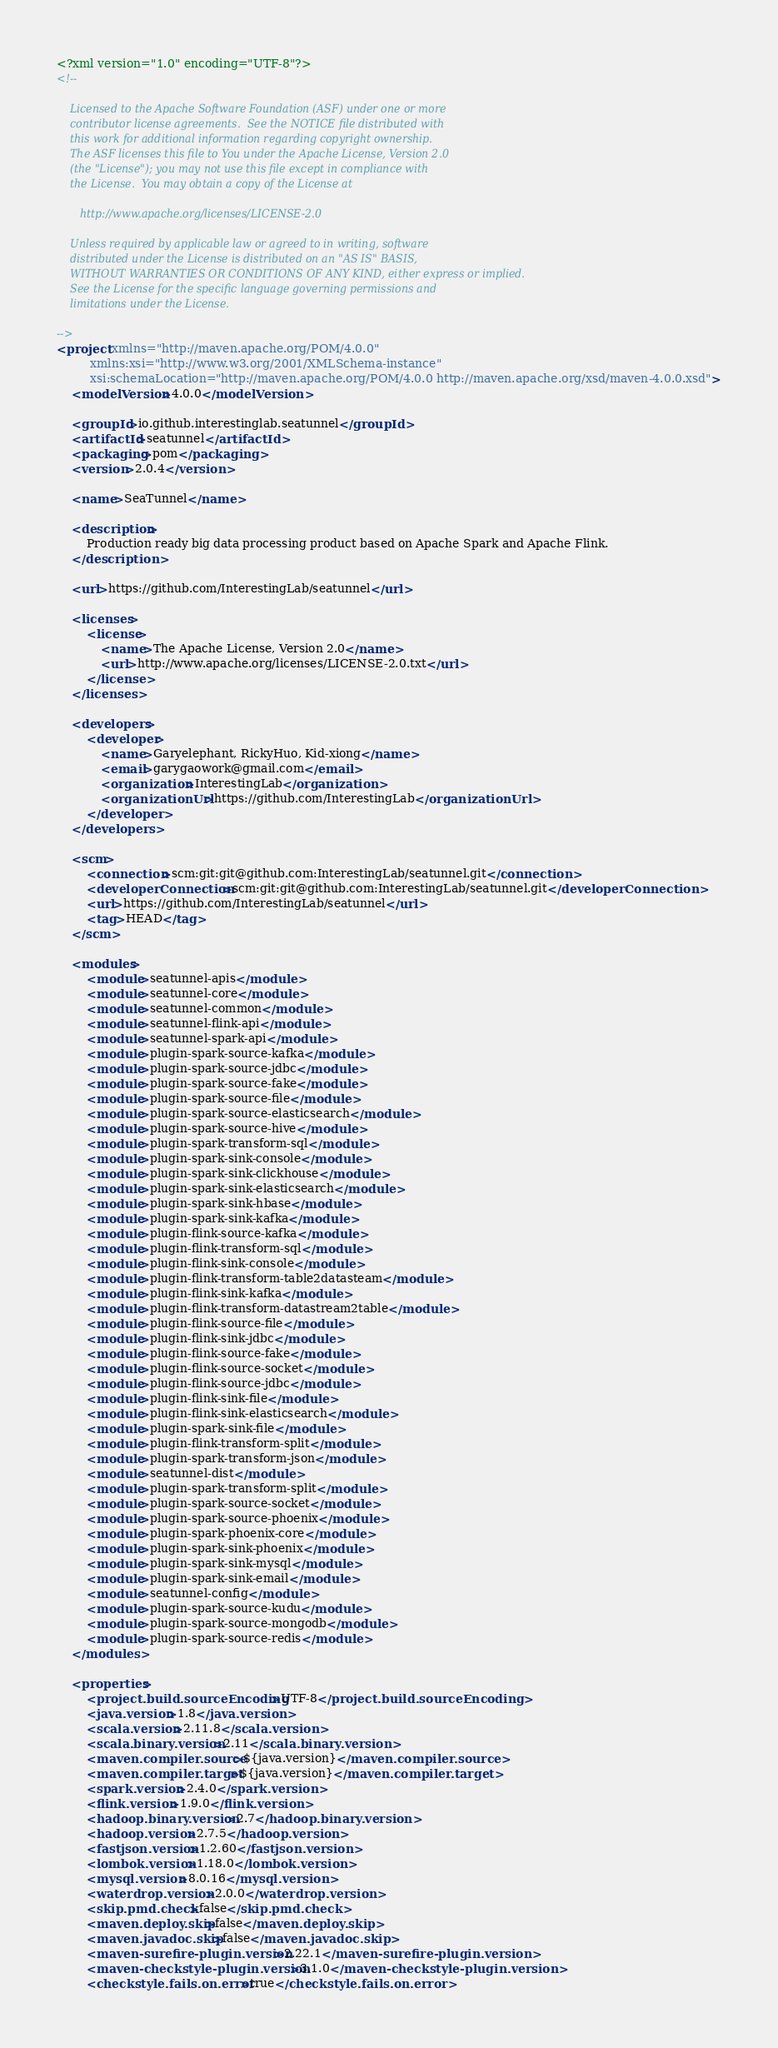<code> <loc_0><loc_0><loc_500><loc_500><_XML_><?xml version="1.0" encoding="UTF-8"?>
<!--

    Licensed to the Apache Software Foundation (ASF) under one or more
    contributor license agreements.  See the NOTICE file distributed with
    this work for additional information regarding copyright ownership.
    The ASF licenses this file to You under the Apache License, Version 2.0
    (the "License"); you may not use this file except in compliance with
    the License.  You may obtain a copy of the License at

       http://www.apache.org/licenses/LICENSE-2.0

    Unless required by applicable law or agreed to in writing, software
    distributed under the License is distributed on an "AS IS" BASIS,
    WITHOUT WARRANTIES OR CONDITIONS OF ANY KIND, either express or implied.
    See the License for the specific language governing permissions and
    limitations under the License.

-->
<project xmlns="http://maven.apache.org/POM/4.0.0"
         xmlns:xsi="http://www.w3.org/2001/XMLSchema-instance"
         xsi:schemaLocation="http://maven.apache.org/POM/4.0.0 http://maven.apache.org/xsd/maven-4.0.0.xsd">
    <modelVersion>4.0.0</modelVersion>

    <groupId>io.github.interestinglab.seatunnel</groupId>
    <artifactId>seatunnel</artifactId>
    <packaging>pom</packaging>
    <version>2.0.4</version>

    <name>SeaTunnel</name>

    <description>
        Production ready big data processing product based on Apache Spark and Apache Flink.
    </description>

    <url>https://github.com/InterestingLab/seatunnel</url>

    <licenses>
        <license>
            <name>The Apache License, Version 2.0</name>
            <url>http://www.apache.org/licenses/LICENSE-2.0.txt</url>
        </license>
    </licenses>

    <developers>
        <developer>
            <name>Garyelephant, RickyHuo, Kid-xiong</name>
            <email>garygaowork@gmail.com</email>
            <organization>InterestingLab</organization>
            <organizationUrl>https://github.com/InterestingLab</organizationUrl>
        </developer>
    </developers>

    <scm>
        <connection>scm:git:git@github.com:InterestingLab/seatunnel.git</connection>
        <developerConnection>scm:git:git@github.com:InterestingLab/seatunnel.git</developerConnection>
        <url>https://github.com/InterestingLab/seatunnel</url>
        <tag>HEAD</tag>
    </scm>

    <modules>
        <module>seatunnel-apis</module>
        <module>seatunnel-core</module>
        <module>seatunnel-common</module>
        <module>seatunnel-flink-api</module>
        <module>seatunnel-spark-api</module>
        <module>plugin-spark-source-kafka</module>
        <module>plugin-spark-source-jdbc</module>
        <module>plugin-spark-source-fake</module>
        <module>plugin-spark-source-file</module>
        <module>plugin-spark-source-elasticsearch</module>
        <module>plugin-spark-source-hive</module>
        <module>plugin-spark-transform-sql</module>
        <module>plugin-spark-sink-console</module>
        <module>plugin-spark-sink-clickhouse</module>
        <module>plugin-spark-sink-elasticsearch</module>
        <module>plugin-spark-sink-hbase</module>
        <module>plugin-spark-sink-kafka</module>
        <module>plugin-flink-source-kafka</module>
        <module>plugin-flink-transform-sql</module>
        <module>plugin-flink-sink-console</module>
        <module>plugin-flink-transform-table2datasteam</module>
        <module>plugin-flink-sink-kafka</module>
        <module>plugin-flink-transform-datastream2table</module>
        <module>plugin-flink-source-file</module>
        <module>plugin-flink-sink-jdbc</module>
        <module>plugin-flink-source-fake</module>
        <module>plugin-flink-source-socket</module>
        <module>plugin-flink-source-jdbc</module>
        <module>plugin-flink-sink-file</module>
        <module>plugin-flink-sink-elasticsearch</module>
        <module>plugin-spark-sink-file</module>
        <module>plugin-flink-transform-split</module>
        <module>plugin-spark-transform-json</module>
        <module>seatunnel-dist</module>
        <module>plugin-spark-transform-split</module>
        <module>plugin-spark-source-socket</module>
        <module>plugin-spark-source-phoenix</module>
        <module>plugin-spark-phoenix-core</module>
        <module>plugin-spark-sink-phoenix</module>
        <module>plugin-spark-sink-mysql</module>
        <module>plugin-spark-sink-email</module>
        <module>seatunnel-config</module>
        <module>plugin-spark-source-kudu</module>
        <module>plugin-spark-source-mongodb</module>
        <module>plugin-spark-source-redis</module>
    </modules>

    <properties>
        <project.build.sourceEncoding>UTF-8</project.build.sourceEncoding>
        <java.version>1.8</java.version>
        <scala.version>2.11.8</scala.version>
        <scala.binary.version>2.11</scala.binary.version>
        <maven.compiler.source>${java.version}</maven.compiler.source>
        <maven.compiler.target>${java.version}</maven.compiler.target>
        <spark.version>2.4.0</spark.version>
        <flink.version>1.9.0</flink.version>
        <hadoop.binary.version>2.7</hadoop.binary.version>
        <hadoop.version>2.7.5</hadoop.version>
        <fastjson.version>1.2.60</fastjson.version>
        <lombok.version>1.18.0</lombok.version>
        <mysql.version>8.0.16</mysql.version>
        <waterdrop.version>2.0.0</waterdrop.version>
        <skip.pmd.check>false</skip.pmd.check>
        <maven.deploy.skip>false</maven.deploy.skip>
        <maven.javadoc.skip>false</maven.javadoc.skip>
        <maven-surefire-plugin.version>2.22.1</maven-surefire-plugin.version>
        <maven-checkstyle-plugin.version>3.1.0</maven-checkstyle-plugin.version>
        <checkstyle.fails.on.error>true</checkstyle.fails.on.error></code> 